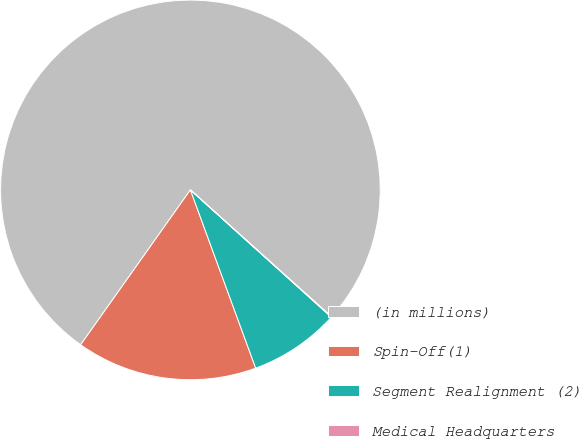<chart> <loc_0><loc_0><loc_500><loc_500><pie_chart><fcel>(in millions)<fcel>Spin-Off(1)<fcel>Segment Realignment (2)<fcel>Medical Headquarters<nl><fcel>76.84%<fcel>15.4%<fcel>7.72%<fcel>0.04%<nl></chart> 